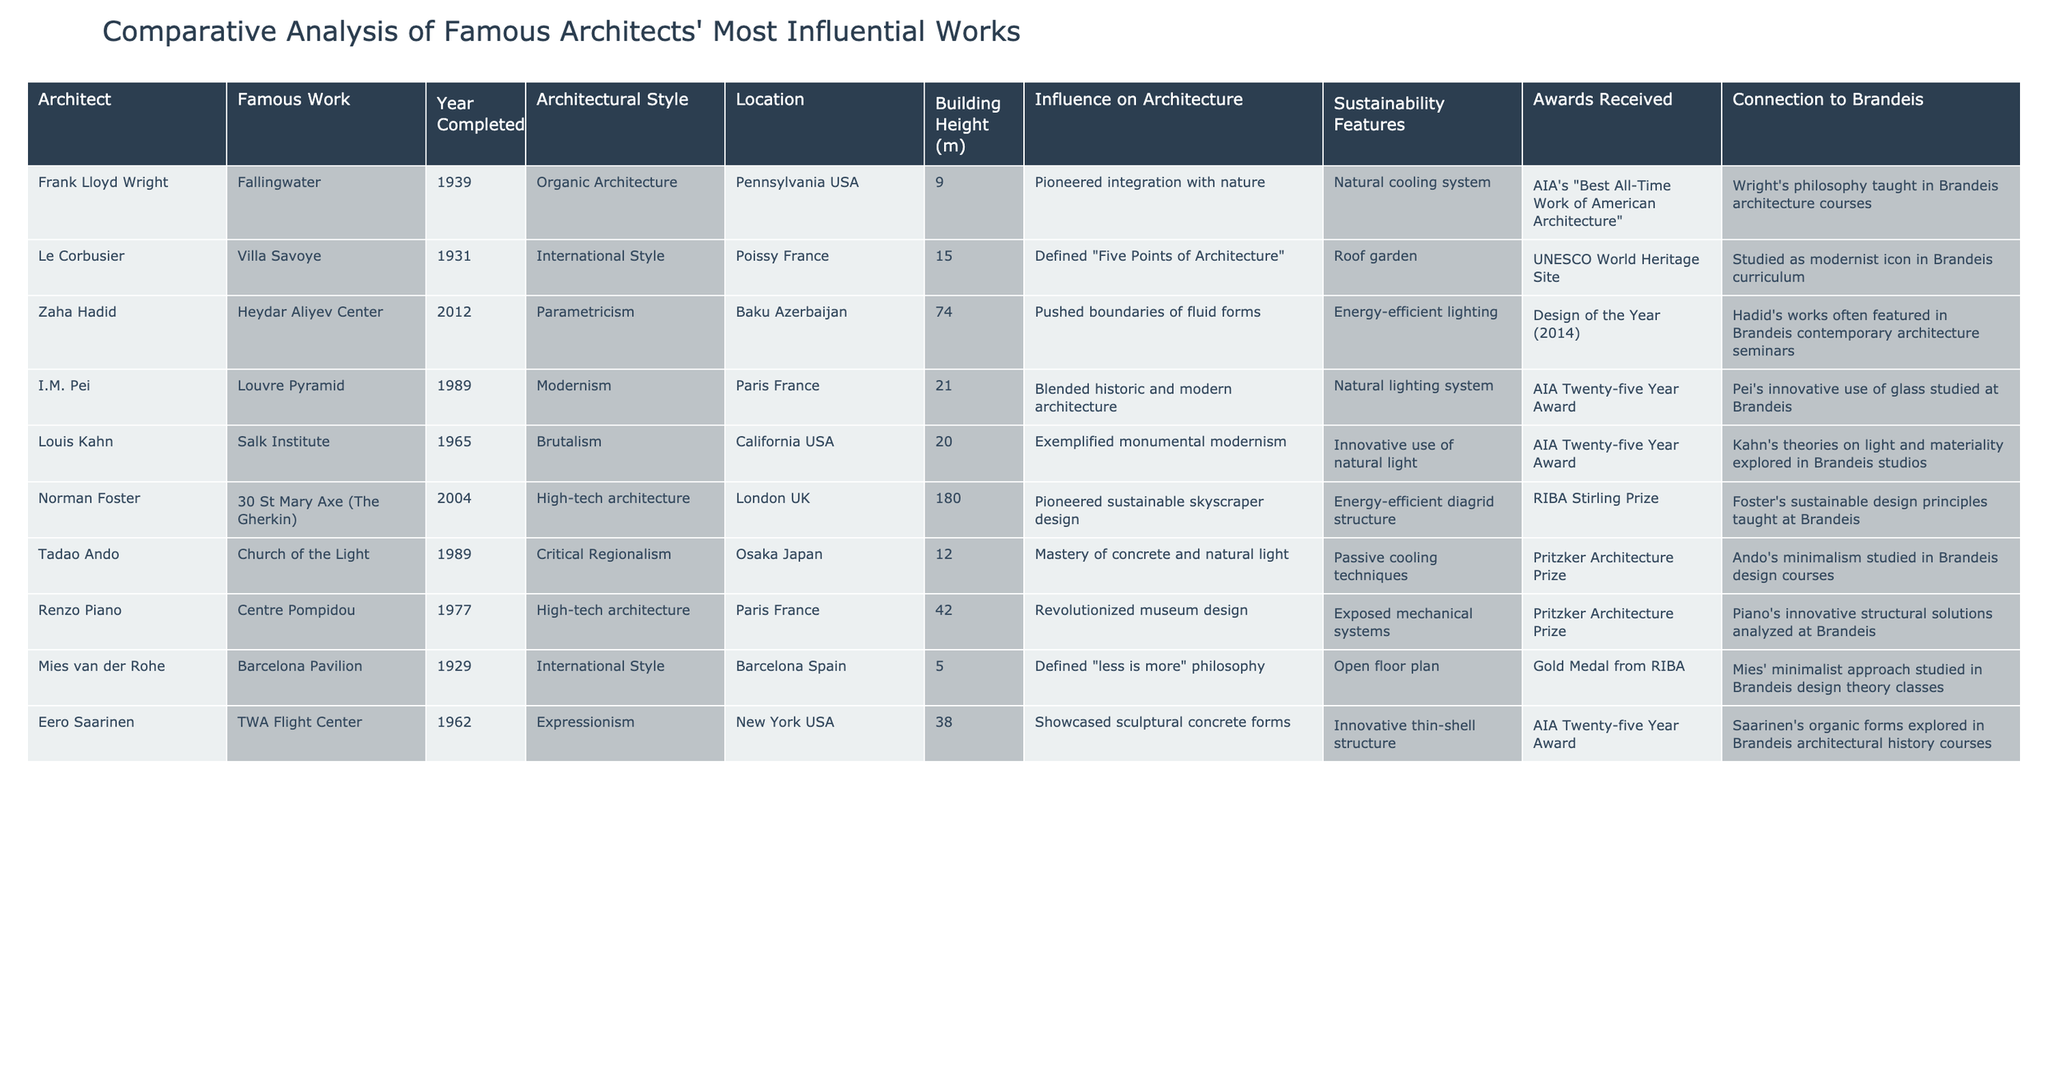What is the architectural style of Fallingwater? The table lists Fallingwater under the architectural style column, indicating it is categorized as "Organic Architecture."
Answer: Organic Architecture Which architect designed the Church of the Light? By referring to the table, we see that Tadao Ando is listed as the architect of the Church of the Light.
Answer: Tadao Ando How many awards did Zaha Hadid receive for the Heydar Aliyev Center? The table specifies that Zaha Hadid received the "Design of the Year (2014)" award for the Heydar Aliyev Center, indicating one award.
Answer: One award What is the highest building height among the listed works? When looking at the building height column, the highest recorded height is 180 meters for 30 St Mary Axe (The Gherkin).
Answer: 180 meters Which architects’ works include sustainable features? The table lists sustainability features for several architects, including Frank Lloyd Wright, Norman Foster, and Tadao Ando, indicating multiple architects are focused on sustainability.
Answer: Multiple architects What is the average height of the buildings listed? Calculating the average height involves adding all heights: 9 + 15 + 74 + 21 + 20 + 180 + 12 + 42 + 5 + 38 = 416. There are 10 buildings, so the average height is 416/10 = 41.6.
Answer: 41.6 meters Did I.M. Pei's Louvre Pyramid receive a Pritzker Architecture Prize? Checking the awards column, the Louvre Pyramid received the "AIA Twenty-five Year Award," not the Pritzker Prize.
Answer: No Which work has both a roof garden and received UNESCO World Heritage status? Referring to the table, Villa Savoye has a roof garden and is marked as a UNESCO World Heritage Site, satisfying the conditions.
Answer: Villa Savoye How many works were completed in the 20th century? By examining the year completed column, we find six works listed (Fallingwater, Villa Savoye, Salk Institute, Barcelona Pavilion, TWA Flight Center, and the Louvre Pyramid) completed between 1900 and 1999.
Answer: Six works Which architect has a direct connection to Brandeis through the study of minimalist design? The table states that Tadao Ando's minimalism is studied in Brandeis design courses, establishing a direct connection through educational courses.
Answer: Tadao Ando 